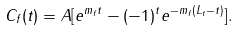<formula> <loc_0><loc_0><loc_500><loc_500>C _ { f } ( t ) = A [ e ^ { m _ { f } t } - ( - 1 ) ^ { t } e ^ { - m _ { f } ( L _ { t } - t ) } ] .</formula> 